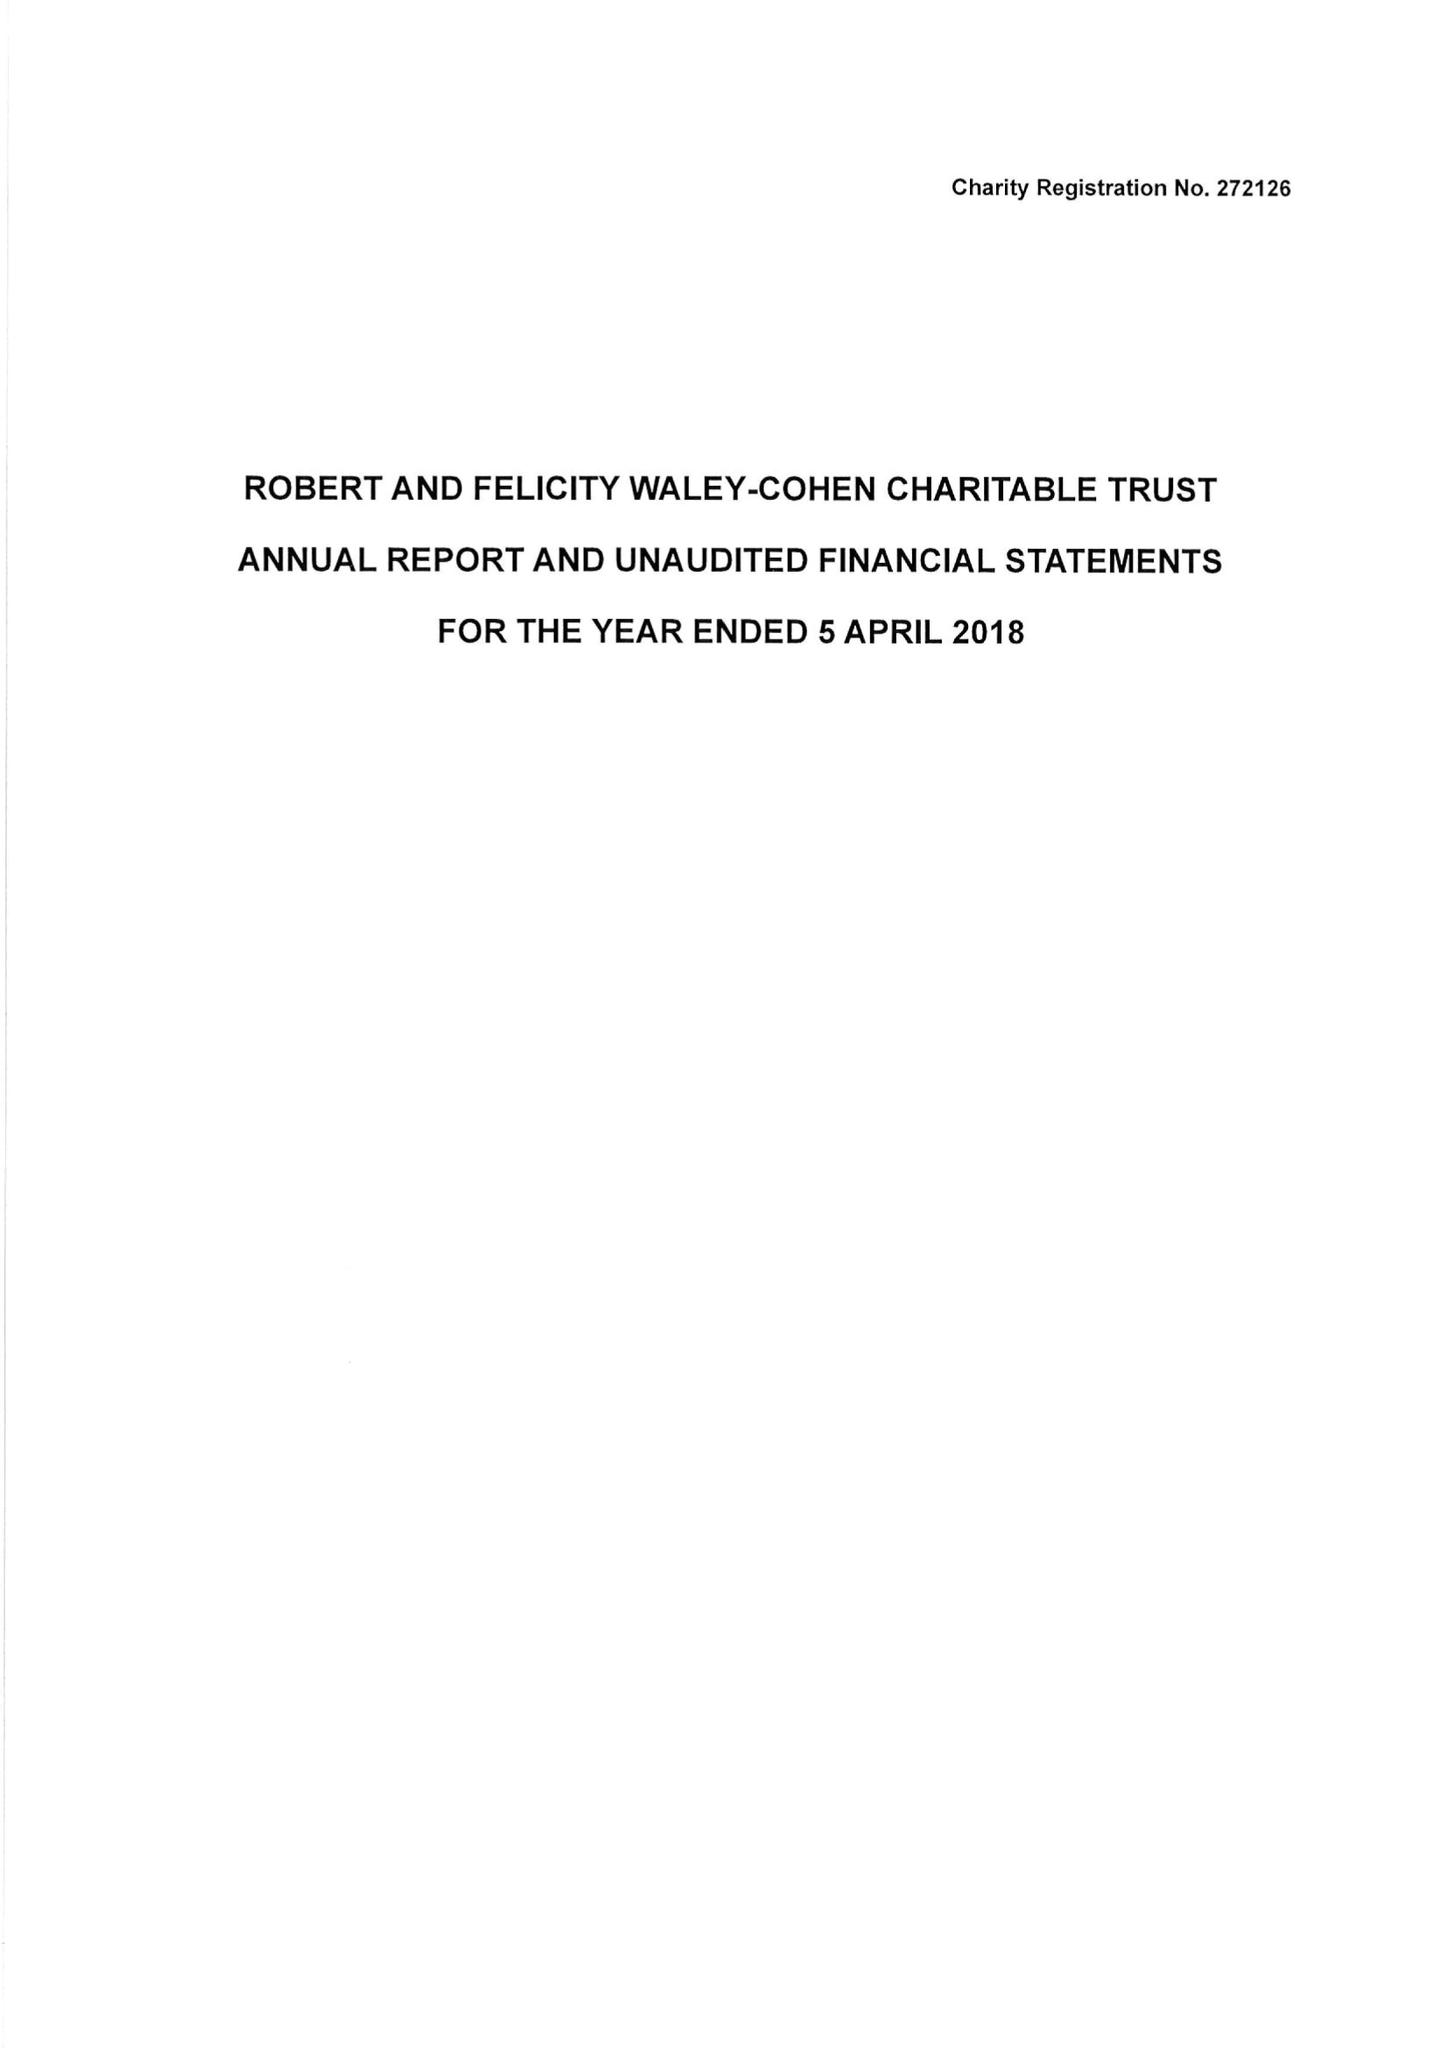What is the value for the report_date?
Answer the question using a single word or phrase. 2018-04-05 